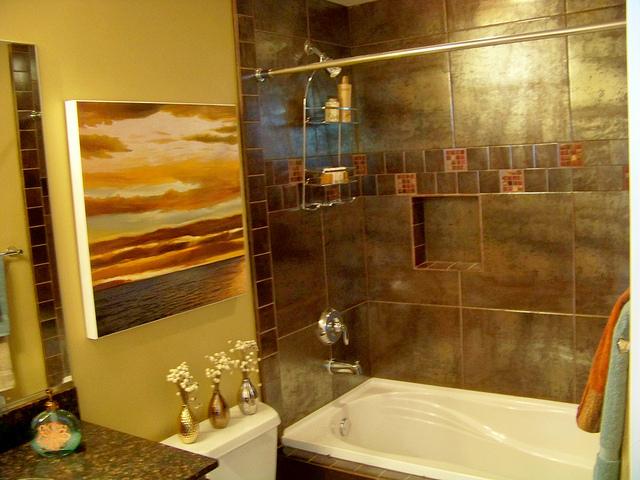Are there any flowers in the bathroom?
Write a very short answer. Yes. Can you identify the type of tile in the tub?
Quick response, please. No. Are there warm, Earthy tones in this image?
Short answer required. Yes. 